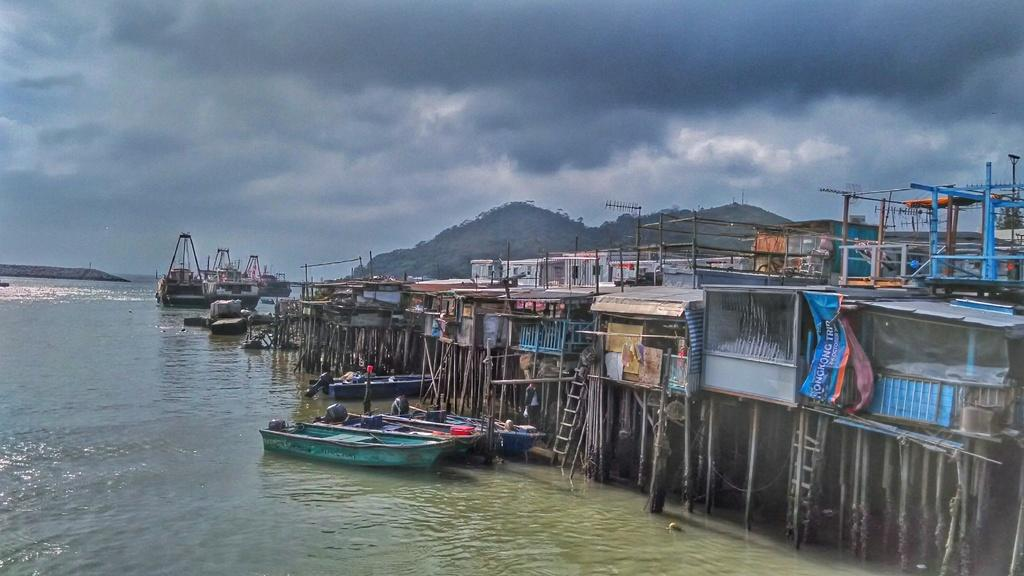What is the main element in the image? There is water in the image. What types of vehicles can be seen in the image? There are boats in the image. What objects are made of wood in the image? Wooden sticks are visible in the image. What equipment is used for climbing in the image? Ladders are present in the image. What type of establishments can be seen in the image? Stores are in the image. What decorative items are present in the image? Banners are in the image. What natural landforms are visible in the image? Mountains are visible in the image. How would you describe the weather in the image? The sky is cloudy in the image. Can you describe any other objects in the image? There are objects in the image. What type of bomb can be seen in the image? There is no bomb present in the image. How many balls are visible in the image? There are no balls visible in the image. 